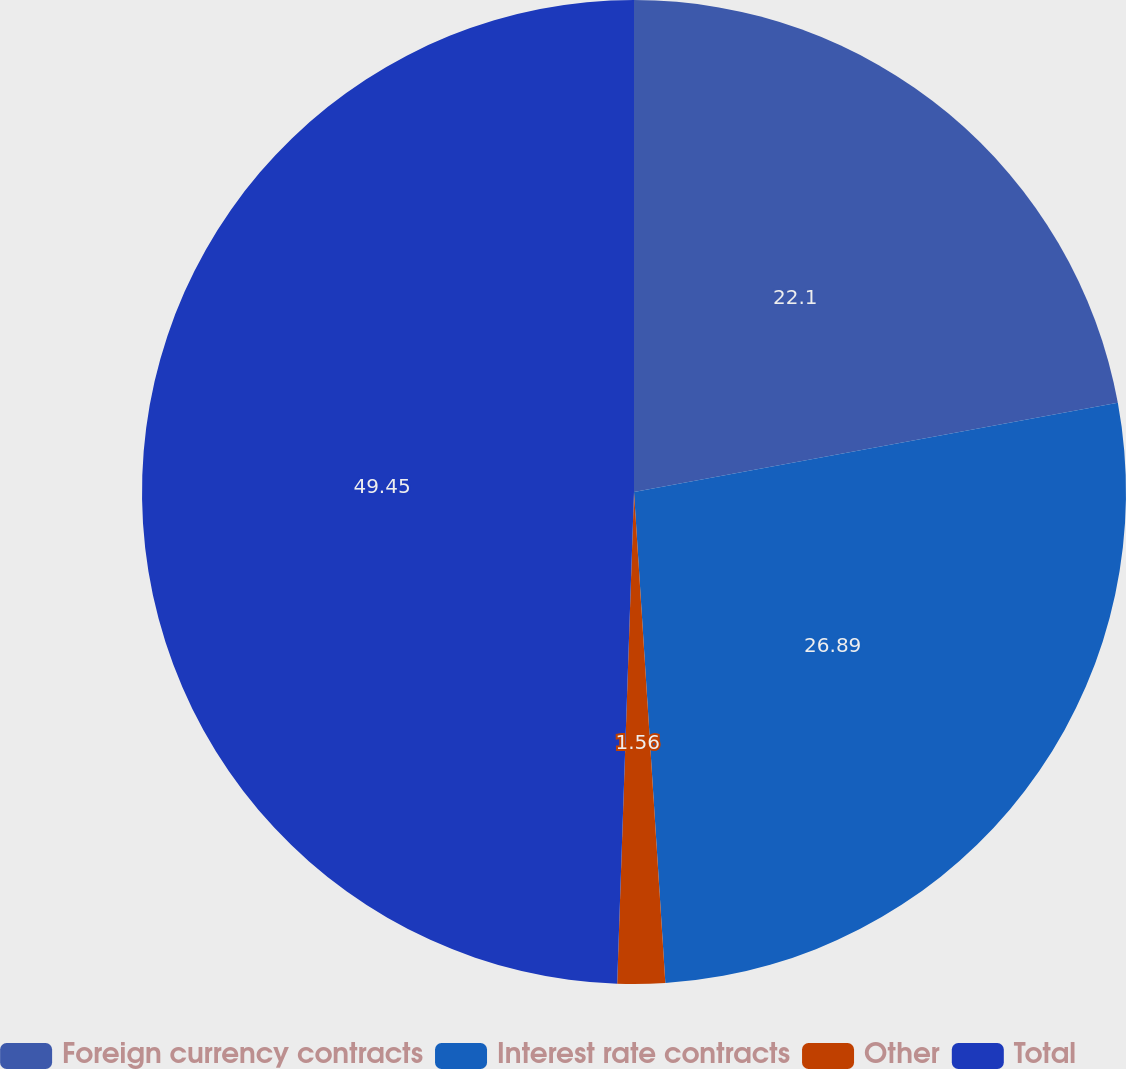Convert chart to OTSL. <chart><loc_0><loc_0><loc_500><loc_500><pie_chart><fcel>Foreign currency contracts<fcel>Interest rate contracts<fcel>Other<fcel>Total<nl><fcel>22.1%<fcel>26.89%<fcel>1.56%<fcel>49.46%<nl></chart> 